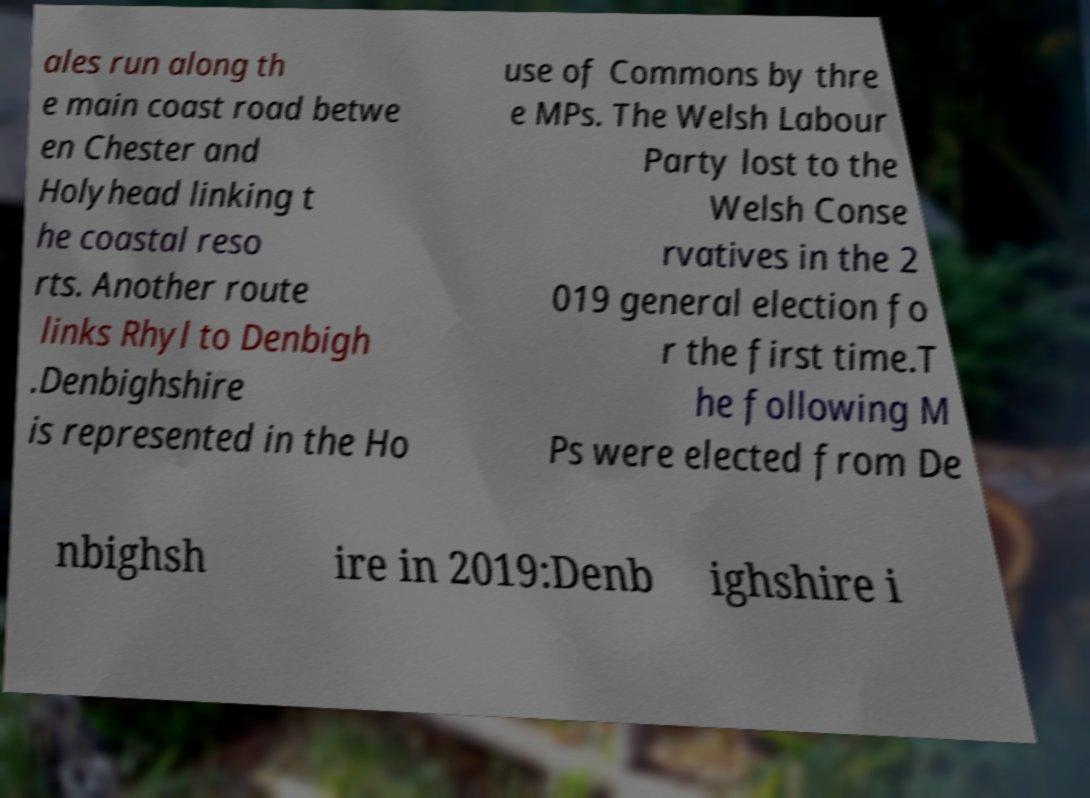For documentation purposes, I need the text within this image transcribed. Could you provide that? ales run along th e main coast road betwe en Chester and Holyhead linking t he coastal reso rts. Another route links Rhyl to Denbigh .Denbighshire is represented in the Ho use of Commons by thre e MPs. The Welsh Labour Party lost to the Welsh Conse rvatives in the 2 019 general election fo r the first time.T he following M Ps were elected from De nbighsh ire in 2019:Denb ighshire i 